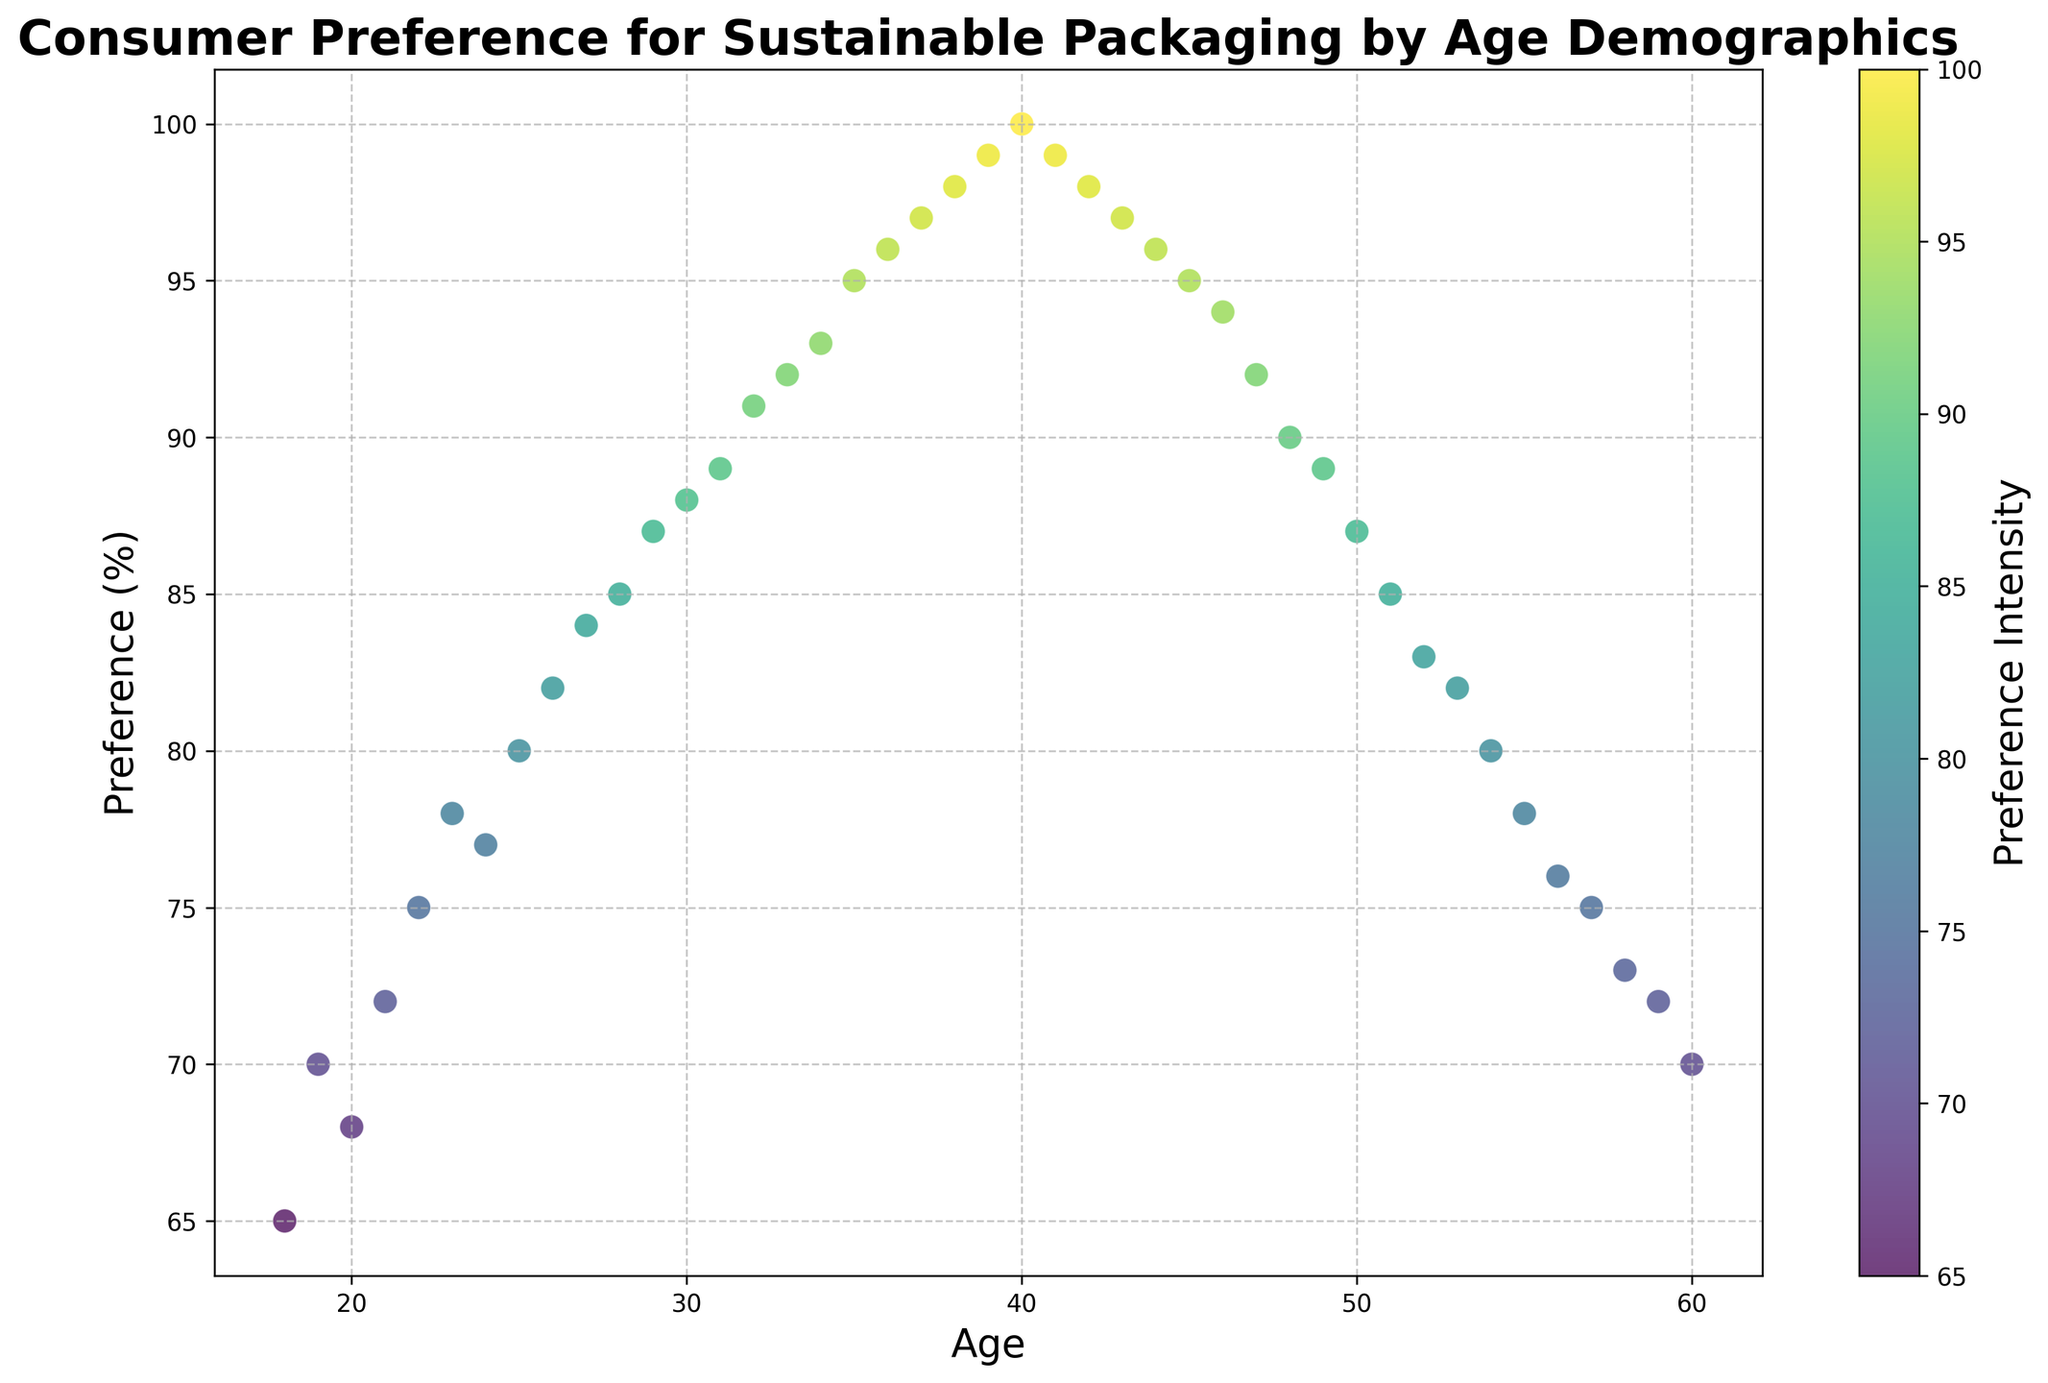What is the preference percentage for the age group 25? Locate the data point on the x-axis corresponding to age 25. Check the y-value of the data point which shows the preference percentage.
Answer: 80 Which age group has the highest preference for sustainable packaging? Find the highest data point on the y-axis and check the corresponding x-value which indicates the age group. In this case, it's at 100% on the y-axis, corresponding to age 40.
Answer: 40 How does the preference for sustainable packaging change between ages 30 and 35? Check the y-values corresponding to ages 30 and 35. At age 30, the preference is 88%, and at age 35, it's 95%. Calculate the difference: 95% - 88% = 7%.
Answer: 7% increase What is the range of preference percentages for individuals aged 40 to 50? Identify the y-values for ages 40 to 50. They range from 100% at age 40 down to 87% at age 50. Calculate the range: 100% - 87% = 13%.
Answer: 13% For which age group is the preference intensity highest according to the color bar? Look at the color intensity in the scatter plot, which correlates to the preference intensity. The most intense color corresponds to the highest percentage, which is 100% at age 40.
Answer: Age 40 What is the trend in preference for sustainable packaging from ages 18 to 30? Analyze the data points from age 18 to 30. The preference generally increases from 65% at age 18 to 88% at age 30.
Answer: Increasing trend How does preference change from age 22 to 23? Check the preference percentage at ages 22 and 23. At age 22, it is 75%, and at age 23, it is 78%. The difference is 78% - 75% = 3%.
Answer: 3% increase Which age groups have the same preference percentage of 97%? Locate the y-values that equal 97% and determine their corresponding x-values (ages). Both age 37 and age 43 show a preference of 97%.
Answer: 37 and 43 Between which ages does the preference for sustainable packaging start to show a downward trend? Find the highest point on the scatter plot and observe the descending pattern. Preferences increase up to age 40 and start to decline after that - from 41 onward.
Answer: Age 41 What's the average preference percentage for ages 50 to 60? Obtain y-values for ages 50 to 60: (87 + 85 + 83 + 82 + 80 + 78 + 76 + 75 + 73 + 72 + 70). Sum them up: 861. Calculate the average by dividing by the number of values: 861 / 11 ~= 78.3%.
Answer: 78.3% 